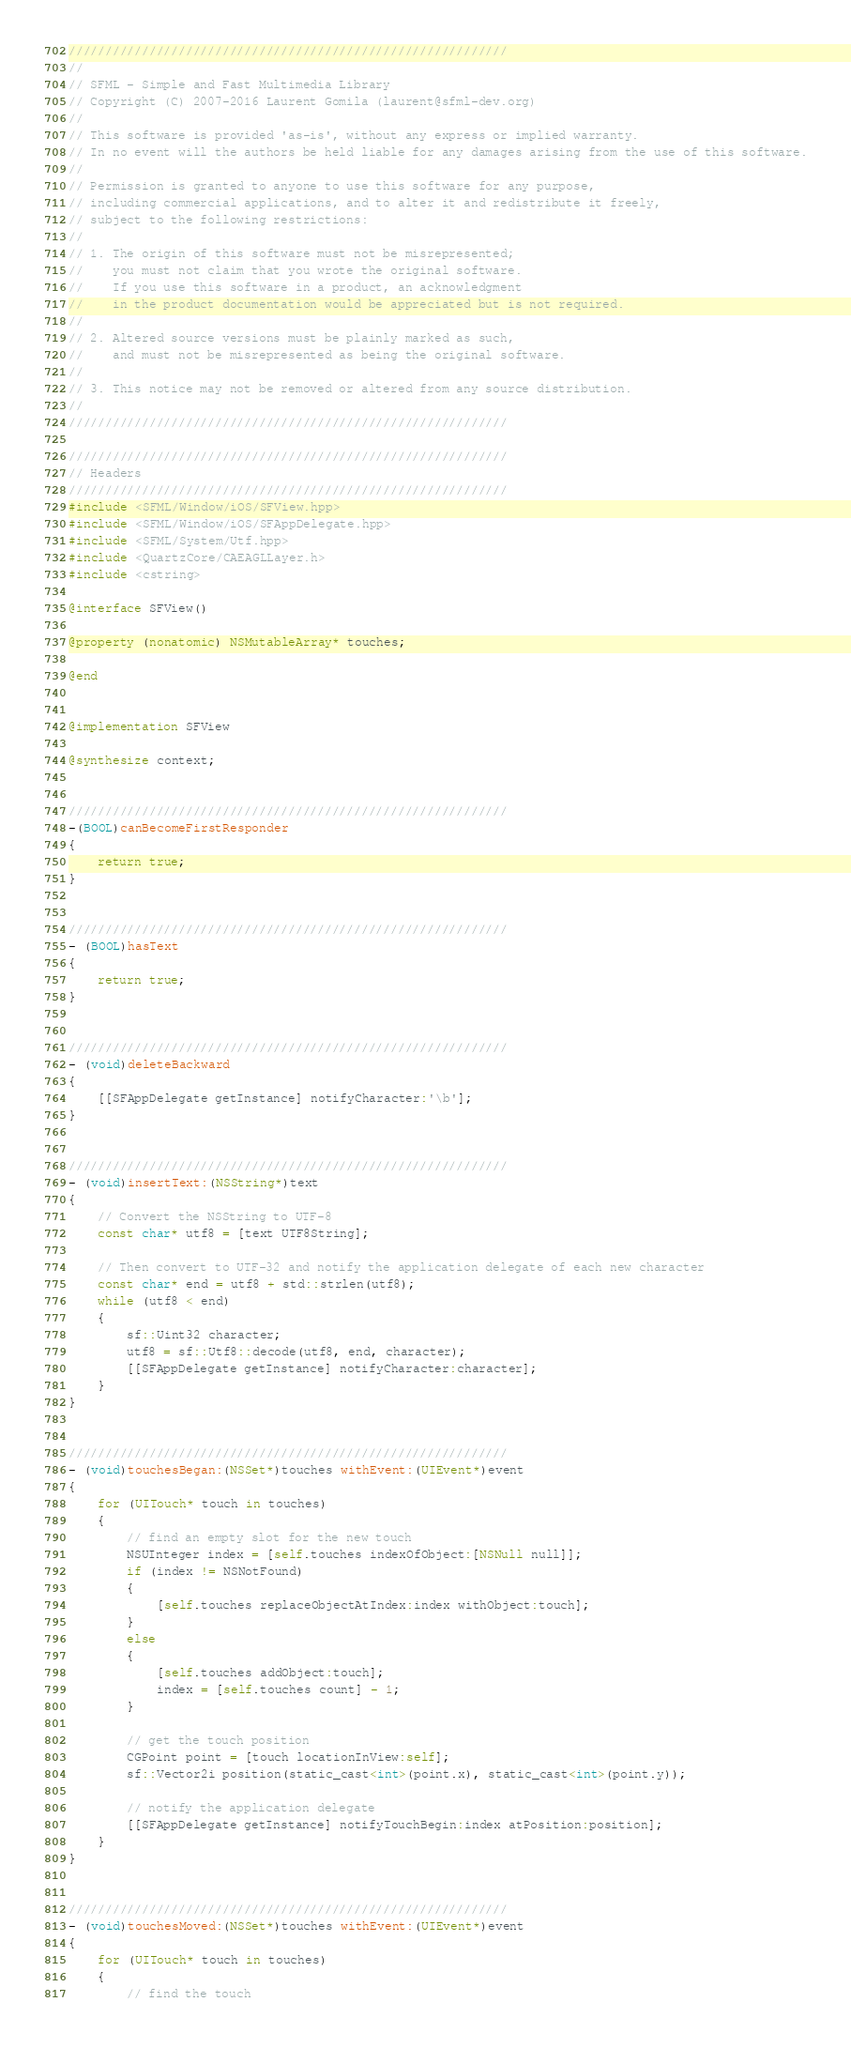Convert code to text. <code><loc_0><loc_0><loc_500><loc_500><_ObjectiveC_>////////////////////////////////////////////////////////////
//
// SFML - Simple and Fast Multimedia Library
// Copyright (C) 2007-2016 Laurent Gomila (laurent@sfml-dev.org)
//
// This software is provided 'as-is', without any express or implied warranty.
// In no event will the authors be held liable for any damages arising from the use of this software.
//
// Permission is granted to anyone to use this software for any purpose,
// including commercial applications, and to alter it and redistribute it freely,
// subject to the following restrictions:
//
// 1. The origin of this software must not be misrepresented;
//    you must not claim that you wrote the original software.
//    If you use this software in a product, an acknowledgment
//    in the product documentation would be appreciated but is not required.
//
// 2. Altered source versions must be plainly marked as such,
//    and must not be misrepresented as being the original software.
//
// 3. This notice may not be removed or altered from any source distribution.
//
////////////////////////////////////////////////////////////

////////////////////////////////////////////////////////////
// Headers
////////////////////////////////////////////////////////////
#include <SFML/Window/iOS/SFView.hpp>
#include <SFML/Window/iOS/SFAppDelegate.hpp>
#include <SFML/System/Utf.hpp>
#include <QuartzCore/CAEAGLLayer.h>
#include <cstring>

@interface SFView()

@property (nonatomic) NSMutableArray* touches;

@end


@implementation SFView

@synthesize context;


////////////////////////////////////////////////////////////
-(BOOL)canBecomeFirstResponder
{
    return true;
}


////////////////////////////////////////////////////////////
- (BOOL)hasText
{
    return true;
}


////////////////////////////////////////////////////////////
- (void)deleteBackward
{
    [[SFAppDelegate getInstance] notifyCharacter:'\b'];
}


////////////////////////////////////////////////////////////
- (void)insertText:(NSString*)text
{
    // Convert the NSString to UTF-8
    const char* utf8 = [text UTF8String];

    // Then convert to UTF-32 and notify the application delegate of each new character
    const char* end = utf8 + std::strlen(utf8);
    while (utf8 < end)
    {
        sf::Uint32 character;
        utf8 = sf::Utf8::decode(utf8, end, character);
        [[SFAppDelegate getInstance] notifyCharacter:character];
    }
}


////////////////////////////////////////////////////////////
- (void)touchesBegan:(NSSet*)touches withEvent:(UIEvent*)event
{
    for (UITouch* touch in touches)
    {
        // find an empty slot for the new touch
        NSUInteger index = [self.touches indexOfObject:[NSNull null]];
        if (index != NSNotFound)
        {
            [self.touches replaceObjectAtIndex:index withObject:touch];
        }
        else
        {
            [self.touches addObject:touch];
            index = [self.touches count] - 1;
        }

        // get the touch position
        CGPoint point = [touch locationInView:self];
        sf::Vector2i position(static_cast<int>(point.x), static_cast<int>(point.y));

        // notify the application delegate
        [[SFAppDelegate getInstance] notifyTouchBegin:index atPosition:position];
    }
}


////////////////////////////////////////////////////////////
- (void)touchesMoved:(NSSet*)touches withEvent:(UIEvent*)event
{
    for (UITouch* touch in touches)
    {
        // find the touch</code> 